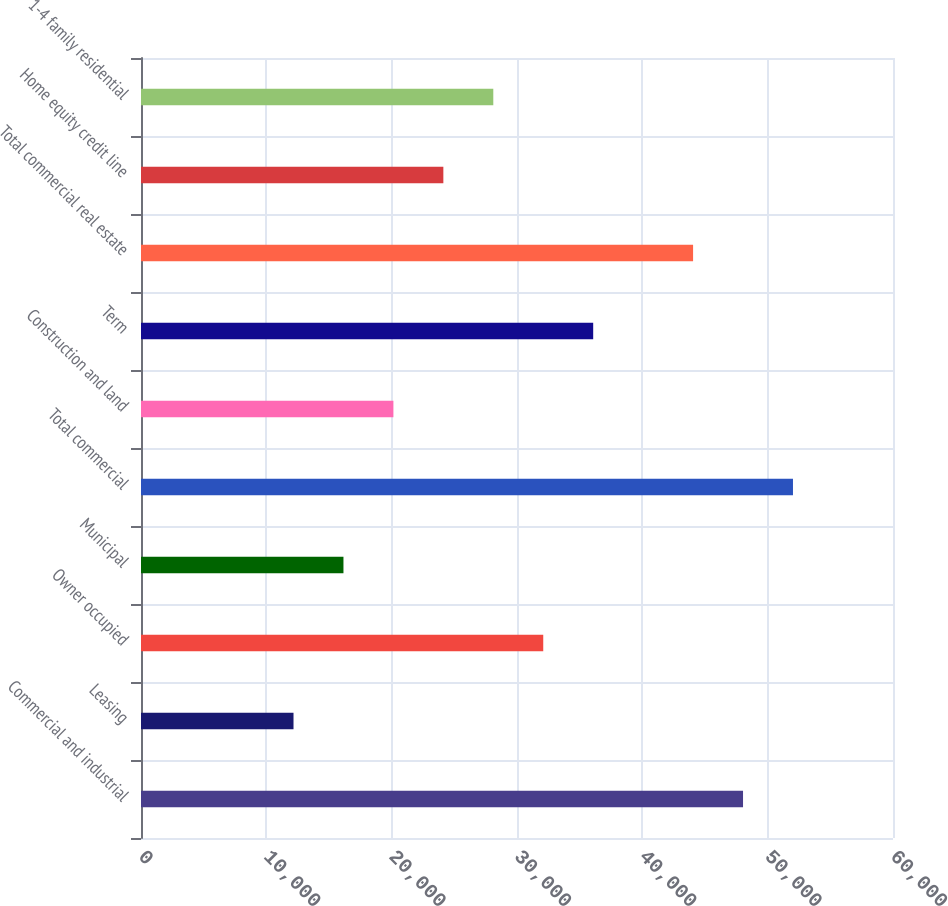<chart> <loc_0><loc_0><loc_500><loc_500><bar_chart><fcel>Commercial and industrial<fcel>Leasing<fcel>Owner occupied<fcel>Municipal<fcel>Total commercial<fcel>Construction and land<fcel>Term<fcel>Total commercial real estate<fcel>Home equity credit line<fcel>1-4 family residential<nl><fcel>48034.2<fcel>12168.3<fcel>32093.8<fcel>16153.4<fcel>52019.3<fcel>20138.5<fcel>36078.9<fcel>44049.1<fcel>24123.6<fcel>28108.7<nl></chart> 